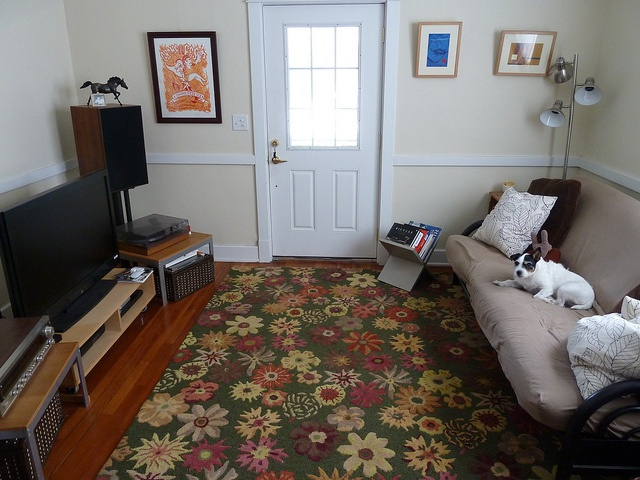Describe the objects in this image and their specific colors. I can see couch in darkgray, gray, and black tones, tv in darkgray, black, and gray tones, dog in darkgray, lightgray, gray, and black tones, book in darkgray, black, and gray tones, and horse in darkgray, black, and gray tones in this image. 